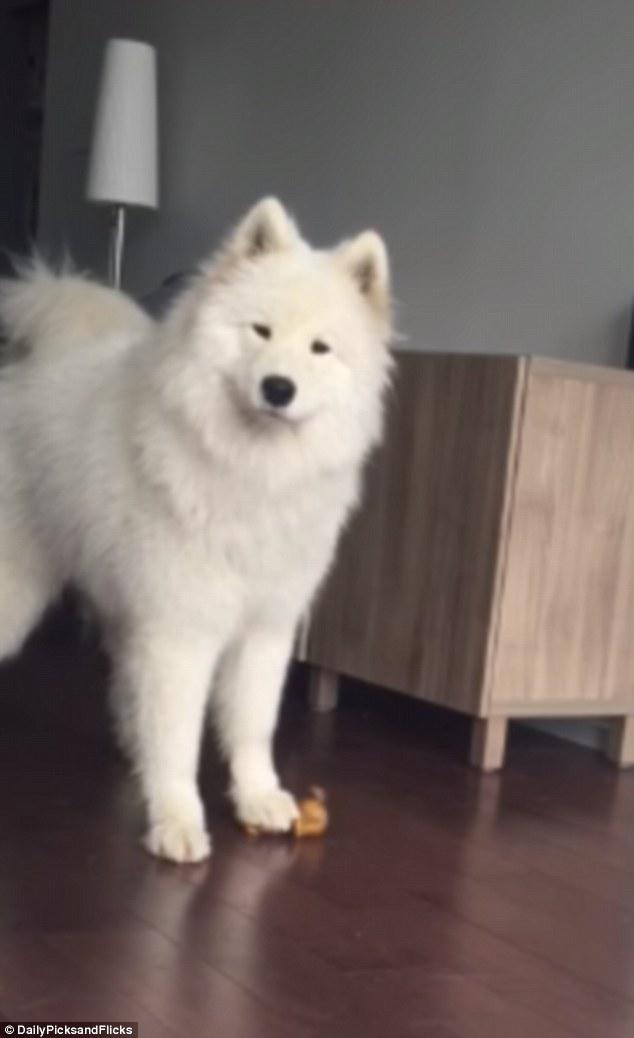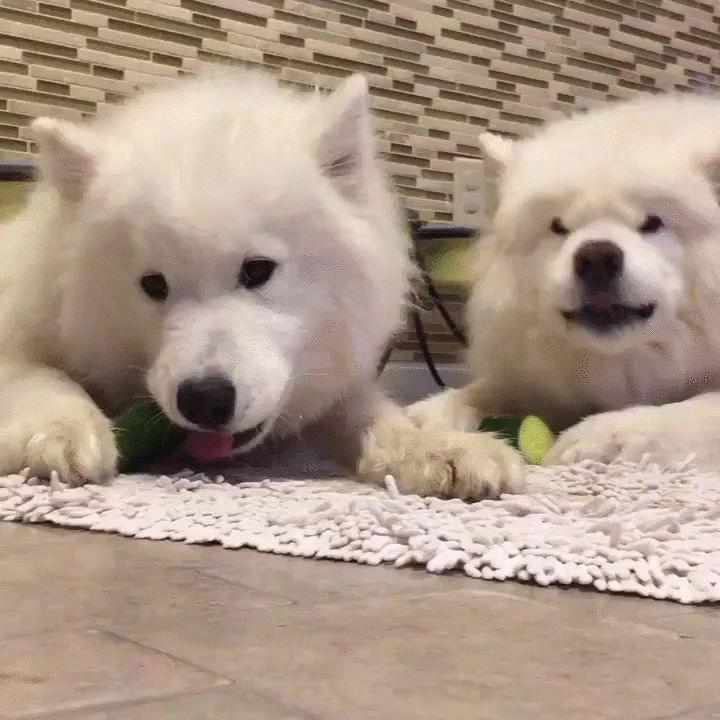The first image is the image on the left, the second image is the image on the right. For the images shown, is this caption "There are three dogs." true? Answer yes or no. Yes. The first image is the image on the left, the second image is the image on the right. Analyze the images presented: Is the assertion "There are at least 2 dogs." valid? Answer yes or no. Yes. 